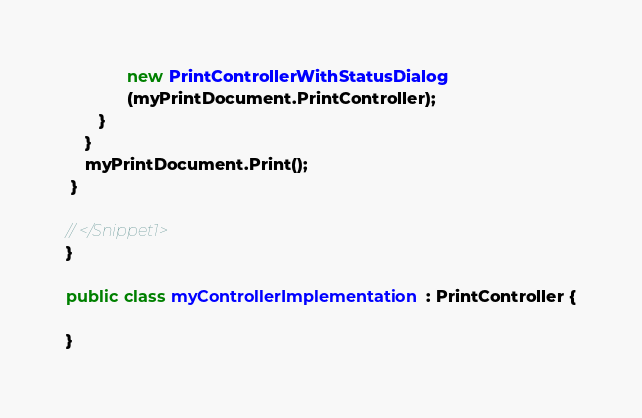Convert code to text. <code><loc_0><loc_0><loc_500><loc_500><_C#_>             new PrintControllerWithStatusDialog
             (myPrintDocument.PrintController);
       }
    }
    myPrintDocument.Print();
 }
 
// </Snippet1>
}

public class myControllerImplementation : PrintController {

}

</code> 